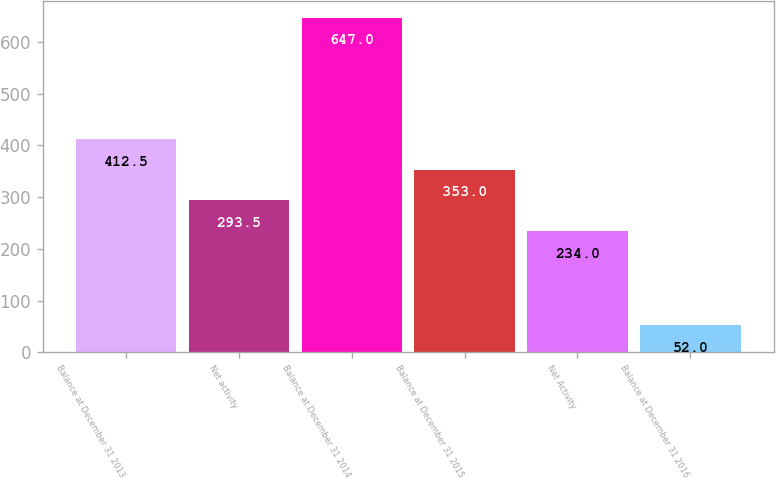Convert chart. <chart><loc_0><loc_0><loc_500><loc_500><bar_chart><fcel>Balance at December 31 2013<fcel>Net activity<fcel>Balance at December 31 2014<fcel>Balance at December 31 2015<fcel>Net Activity<fcel>Balance at December 31 2016<nl><fcel>412.5<fcel>293.5<fcel>647<fcel>353<fcel>234<fcel>52<nl></chart> 